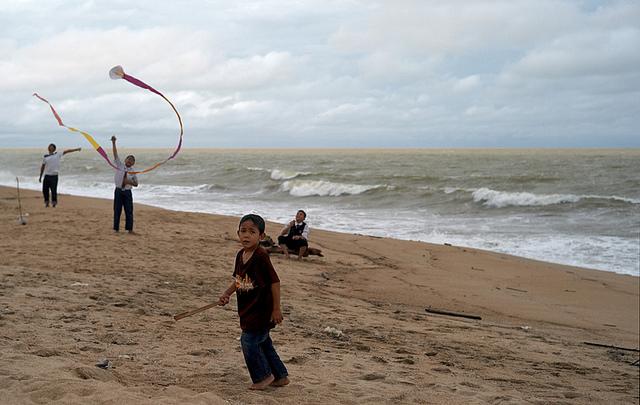How many kids in the photo?
Short answer required. 2. Is there anyone in the water?
Be succinct. No. How many footsteps are in the sand?
Give a very brief answer. Many. How many people in the photo?
Answer briefly. 4. Is that a boy or girl flying the kite?
Give a very brief answer. Boy. Are there people on the land in the background?
Short answer required. Yes. 